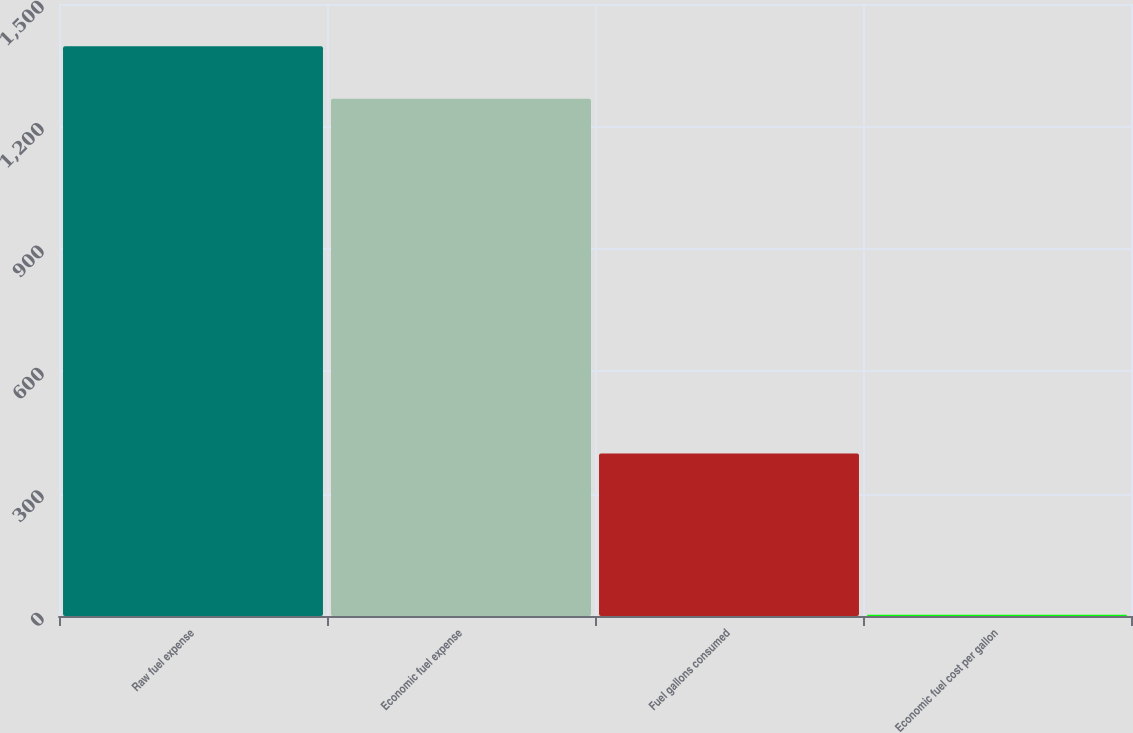Convert chart. <chart><loc_0><loc_0><loc_500><loc_500><bar_chart><fcel>Raw fuel expense<fcel>Economic fuel expense<fcel>Fuel gallons consumed<fcel>Economic fuel cost per gallon<nl><fcel>1396.18<fcel>1267.6<fcel>398.3<fcel>3.18<nl></chart> 